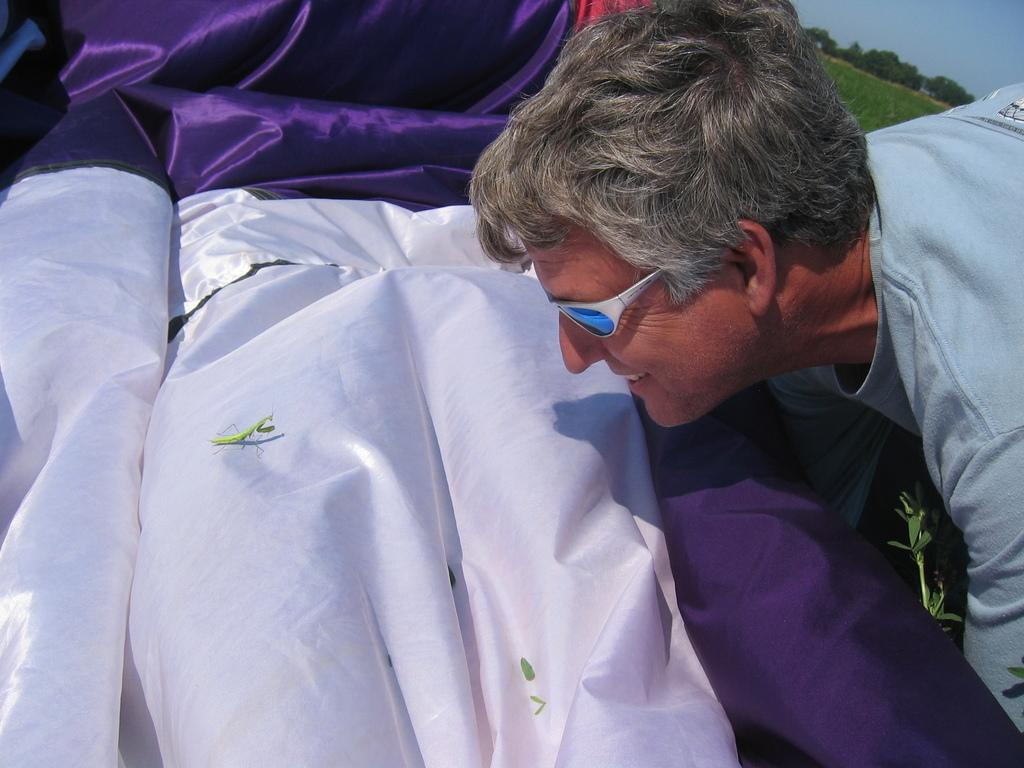What type of insect is present in the image? There is a grasshopper in the image. What else can be seen in the image besides the grasshopper? There are clothes, trees, a plant, and a person wearing glasses in the image. What type of vegetation is present in the image? There are trees and a plant in the image. Can you describe the person in the image? The person in the image is wearing glasses. What is the temperature limit of the roof in the image? There is no roof present in the image, so it is not possible to determine a temperature limit. 